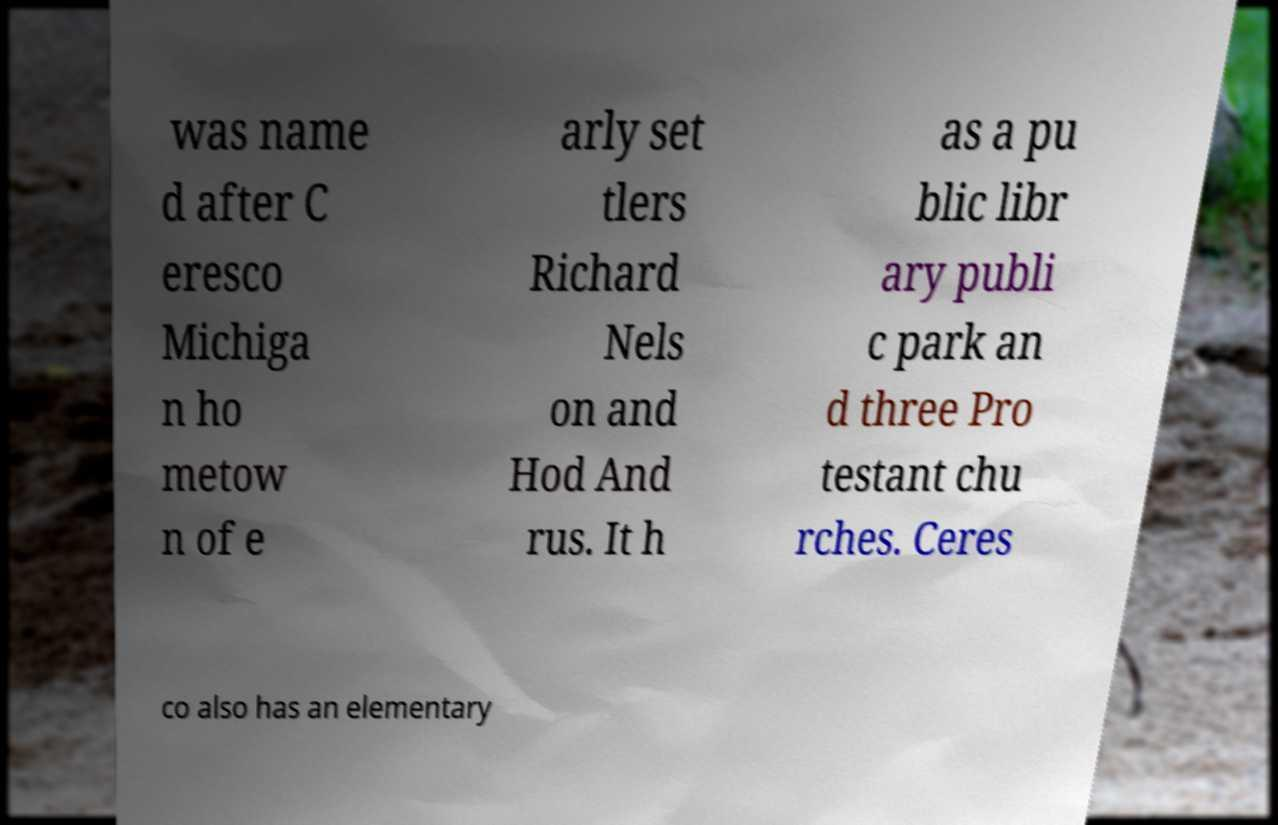There's text embedded in this image that I need extracted. Can you transcribe it verbatim? was name d after C eresco Michiga n ho metow n of e arly set tlers Richard Nels on and Hod And rus. It h as a pu blic libr ary publi c park an d three Pro testant chu rches. Ceres co also has an elementary 